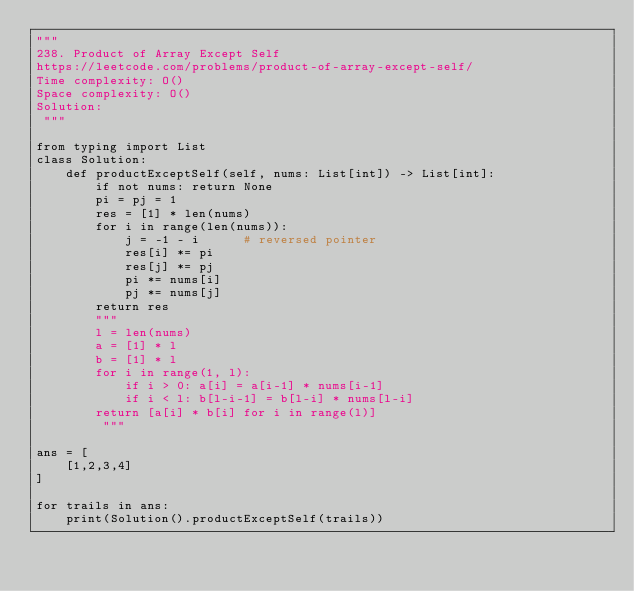<code> <loc_0><loc_0><loc_500><loc_500><_Python_>""" 
238. Product of Array Except Self
https://leetcode.com/problems/product-of-array-except-self/
Time complexity: O()
Space complexity: O()
Solution: 
 """

from typing import List
class Solution:
    def productExceptSelf(self, nums: List[int]) -> List[int]: 
        if not nums: return None
        pi = pj = 1
        res = [1] * len(nums)
        for i in range(len(nums)):
            j = -1 - i      # reversed pointer
            res[i] *= pi
            res[j] *= pj
            pi *= nums[i]
            pj *= nums[j]
        return res
        """
        l = len(nums)
        a = [1] * l
        b = [1] * l
        for i in range(1, l):
            if i > 0: a[i] = a[i-1] * nums[i-1]
            if i < l: b[l-i-1] = b[l-i] * nums[l-i]
        return [a[i] * b[i] for i in range(l)]
         """

ans = [
    [1,2,3,4]
]

for trails in ans:
    print(Solution().productExceptSelf(trails))
</code> 